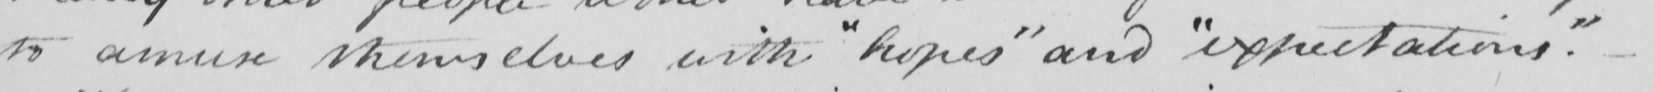What text is written in this handwritten line? to amuse themselves with  " hopes "  and  " expectations "  .  _ 